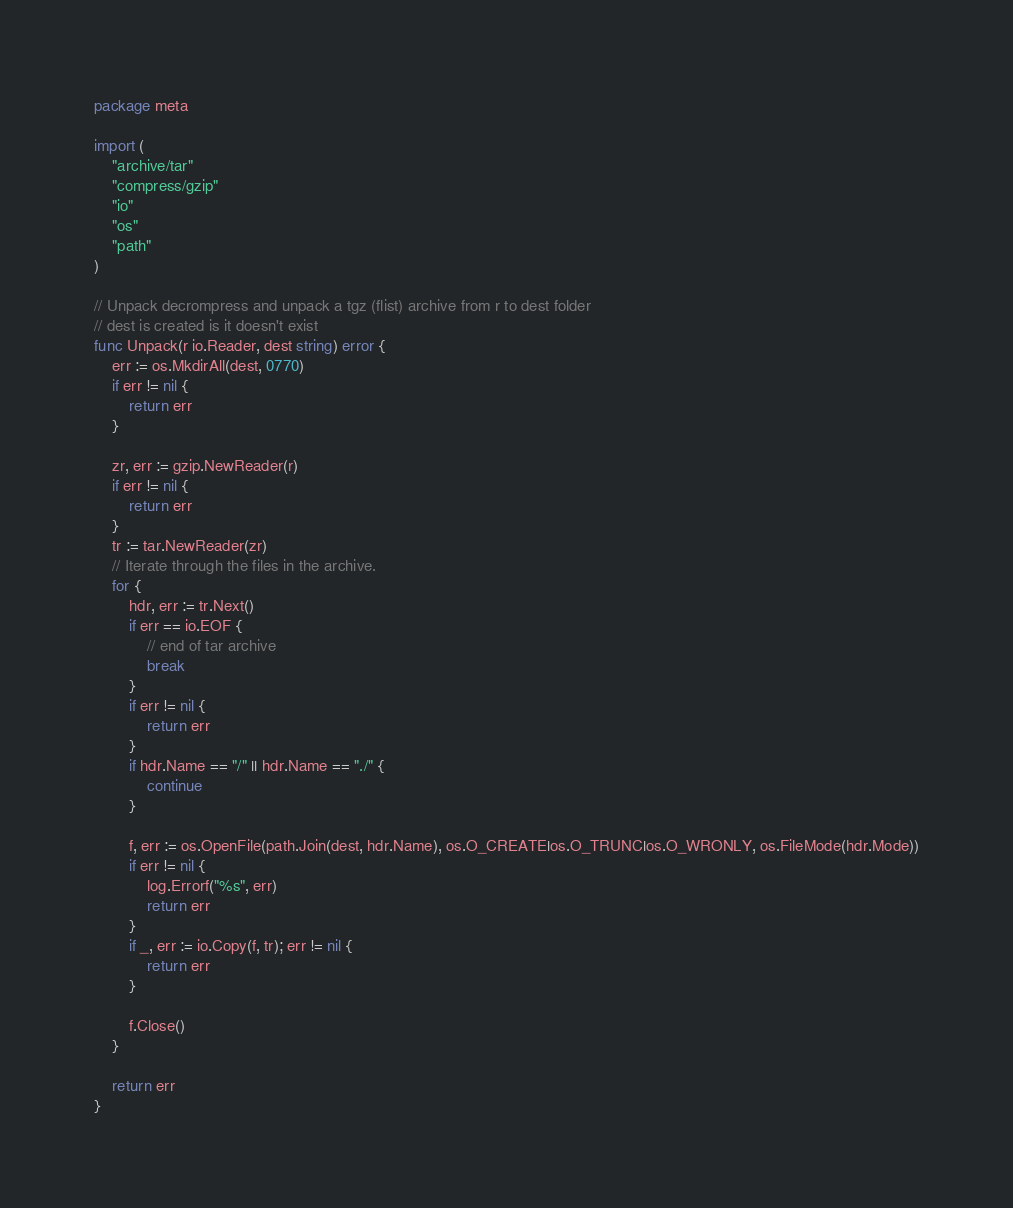Convert code to text. <code><loc_0><loc_0><loc_500><loc_500><_Go_>package meta

import (
	"archive/tar"
	"compress/gzip"
	"io"
	"os"
	"path"
)

// Unpack decrompress and unpack a tgz (flist) archive from r to dest folder
// dest is created is it doesn't exist
func Unpack(r io.Reader, dest string) error {
	err := os.MkdirAll(dest, 0770)
	if err != nil {
		return err
	}

	zr, err := gzip.NewReader(r)
	if err != nil {
		return err
	}
	tr := tar.NewReader(zr)
	// Iterate through the files in the archive.
	for {
		hdr, err := tr.Next()
		if err == io.EOF {
			// end of tar archive
			break
		}
		if err != nil {
			return err
		}
		if hdr.Name == "/" || hdr.Name == "./" {
			continue
		}

		f, err := os.OpenFile(path.Join(dest, hdr.Name), os.O_CREATE|os.O_TRUNC|os.O_WRONLY, os.FileMode(hdr.Mode))
		if err != nil {
			log.Errorf("%s", err)
			return err
		}
		if _, err := io.Copy(f, tr); err != nil {
			return err
		}

		f.Close()
	}

	return err
}
</code> 